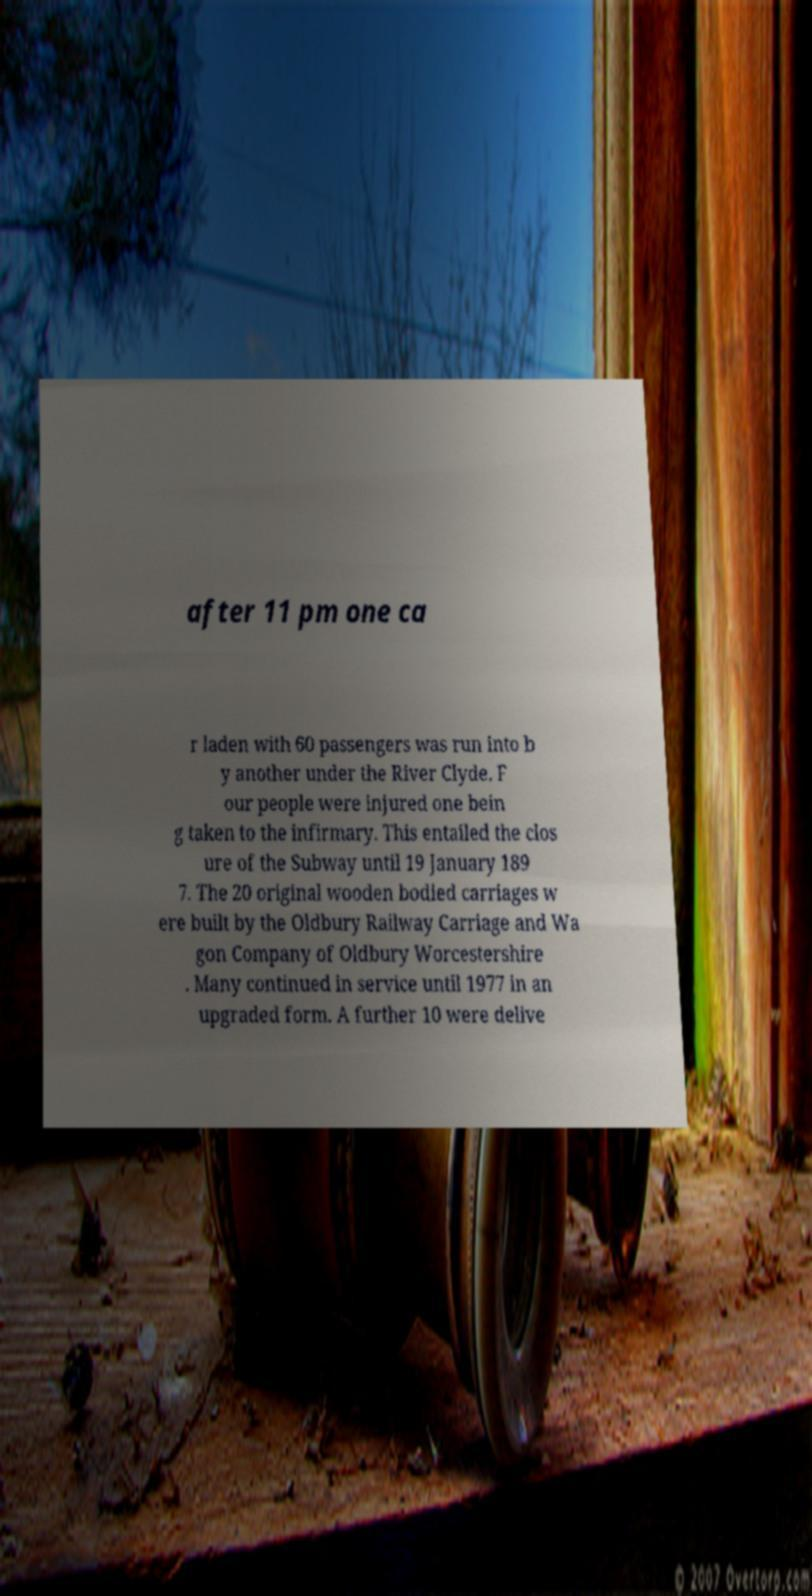Could you extract and type out the text from this image? after 11 pm one ca r laden with 60 passengers was run into b y another under the River Clyde. F our people were injured one bein g taken to the infirmary. This entailed the clos ure of the Subway until 19 January 189 7. The 20 original wooden bodied carriages w ere built by the Oldbury Railway Carriage and Wa gon Company of Oldbury Worcestershire . Many continued in service until 1977 in an upgraded form. A further 10 were delive 